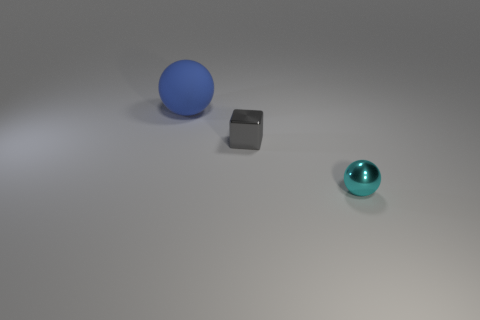How many cyan shiny things are the same size as the cyan ball?
Your answer should be very brief. 0. What is the material of the other object that is the same shape as the small cyan metal thing?
Your response must be concise. Rubber. Is the tiny cyan thing the same shape as the small gray metallic thing?
Your response must be concise. No. How many big rubber objects are in front of the tiny metal sphere?
Offer a very short reply. 0. What is the shape of the shiny thing on the left side of the ball right of the gray metal thing?
Your response must be concise. Cube. There is a small gray thing that is the same material as the tiny cyan thing; what is its shape?
Give a very brief answer. Cube. There is a metal thing that is on the right side of the block; is its size the same as the sphere left of the gray metallic cube?
Give a very brief answer. No. What is the shape of the shiny thing behind the small cyan shiny object?
Your response must be concise. Cube. What is the color of the big rubber sphere?
Provide a short and direct response. Blue. There is a blue rubber object; is its size the same as the ball in front of the blue thing?
Ensure brevity in your answer.  No. 